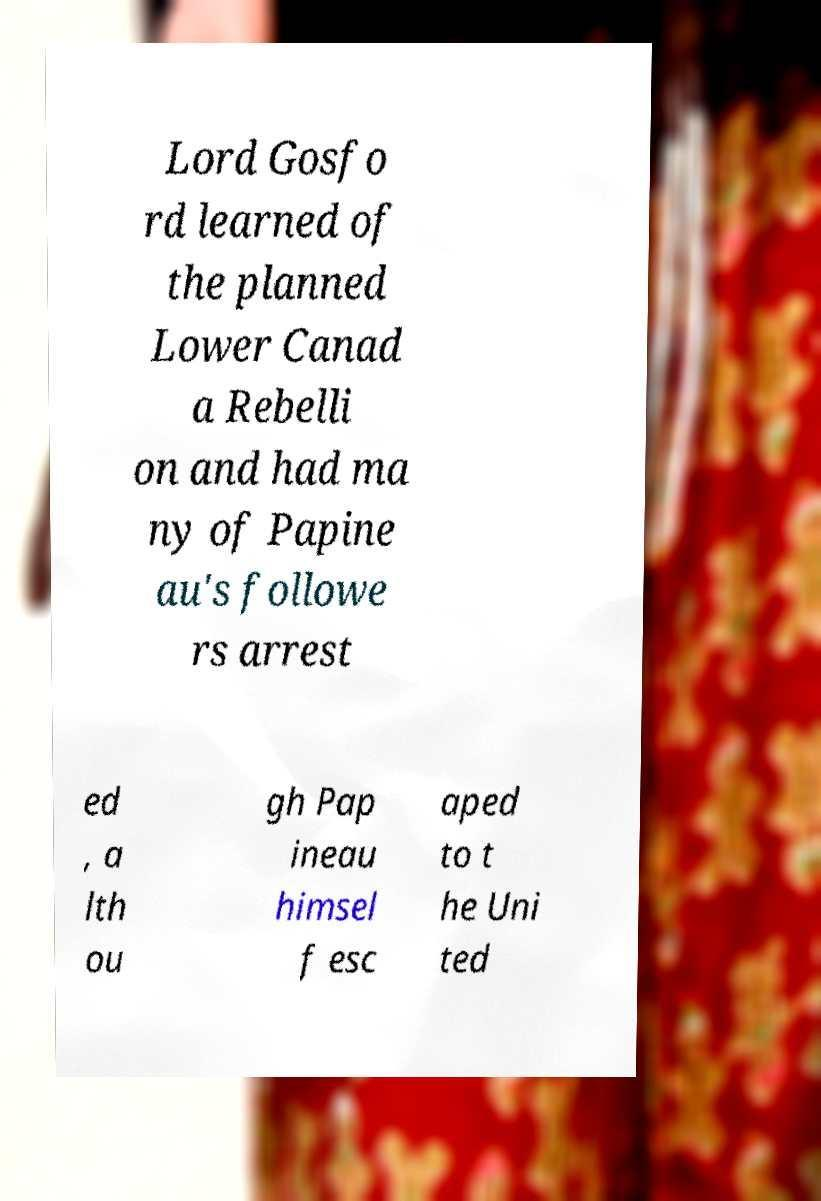Can you read and provide the text displayed in the image?This photo seems to have some interesting text. Can you extract and type it out for me? Lord Gosfo rd learned of the planned Lower Canad a Rebelli on and had ma ny of Papine au's followe rs arrest ed , a lth ou gh Pap ineau himsel f esc aped to t he Uni ted 